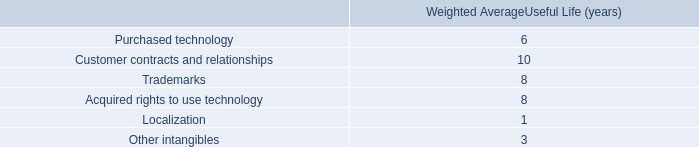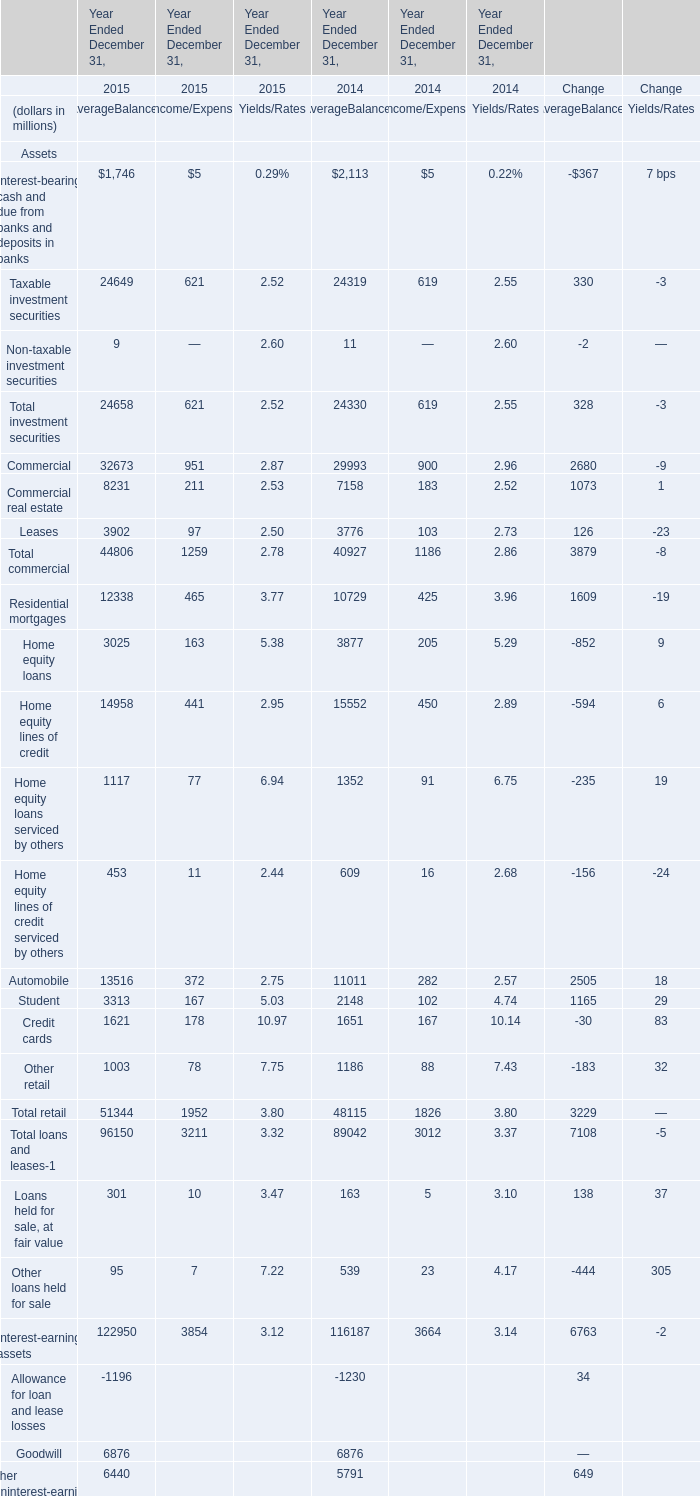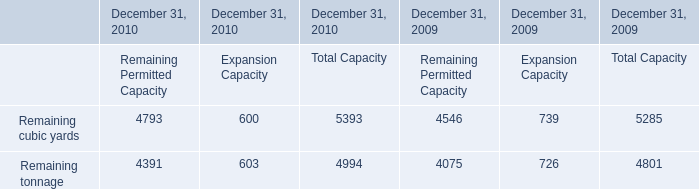In the year with largest amount of Taxable investment securities , what's the sum of Total investment securities? (in million) 
Computations: ((24658 + 621) + 2.52)
Answer: 25281.52. 